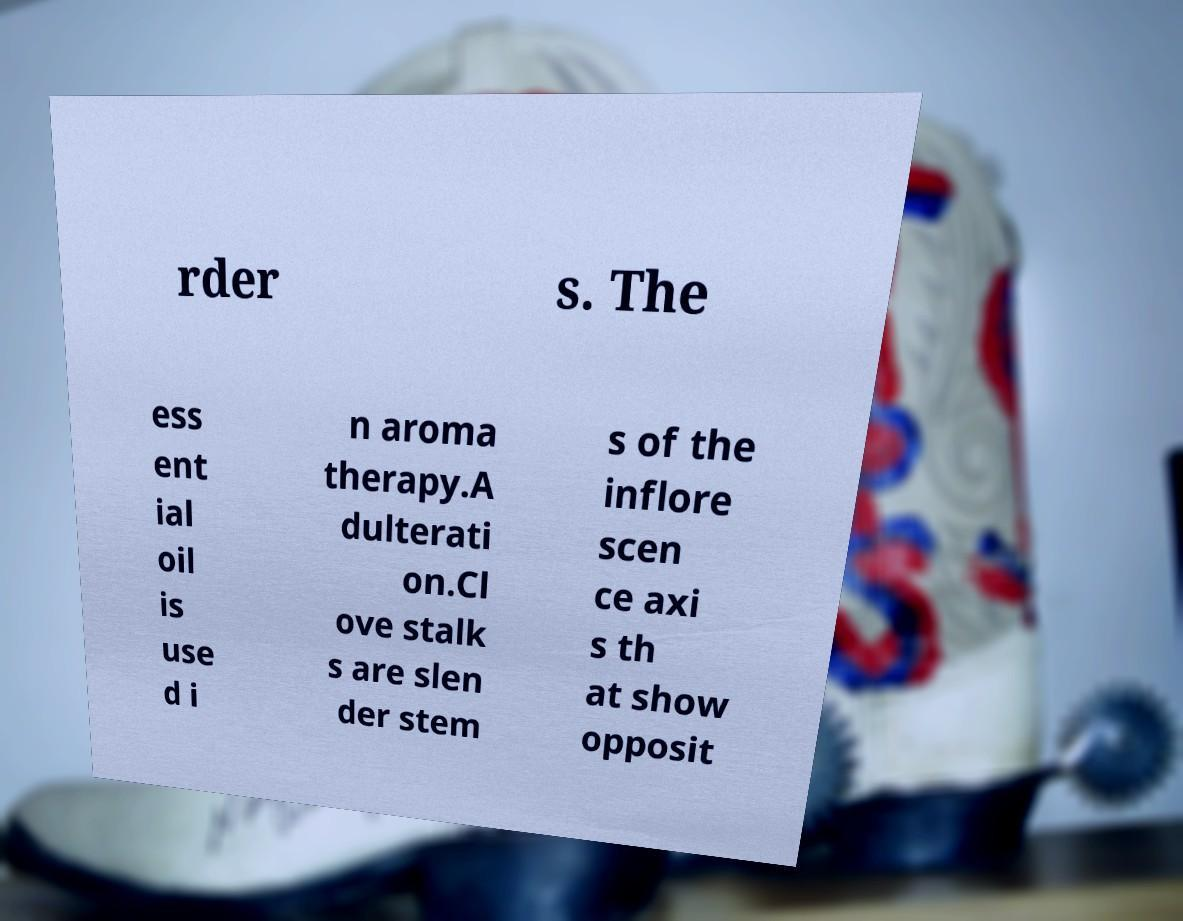For documentation purposes, I need the text within this image transcribed. Could you provide that? rder s. The ess ent ial oil is use d i n aroma therapy.A dulterati on.Cl ove stalk s are slen der stem s of the inflore scen ce axi s th at show opposit 